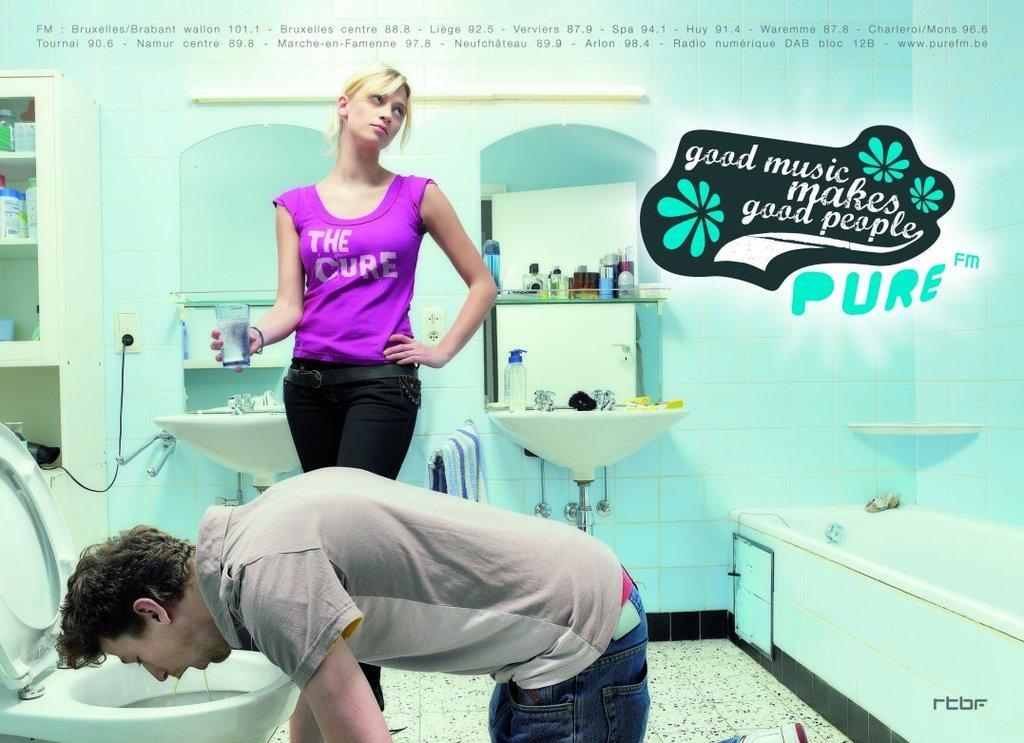Please provide a concise description of this image. This is the picture of a bathroom where we can see a woman standing with a glass of water and to the side there is a man who is vomiting. In this image there is a toilet, bathtub and there is a mirror, racks attached to the wall to the side. There is a sink and some objects are placed on it and to the left corner there is a cupboard where some objects are placed in it. 